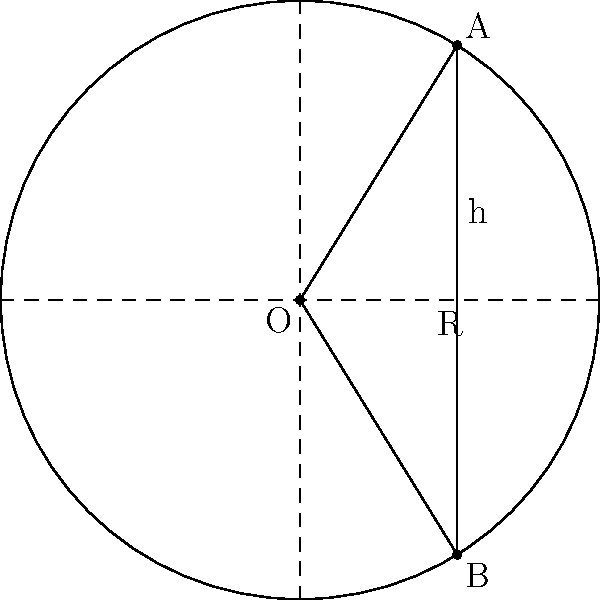A secure communication satellite orbits Earth in a circular path at an altitude of 35,786 km. Two ground stations in Europe, separated by a central angle of 90°, need to establish a connection through this satellite. If the Earth's radius is 6,371 km, what is the minimum distance between the satellite and the chord connecting the two ground stations? Let's approach this step-by-step:

1) First, we need to calculate the total radius of the orbit:
   $R = \text{Earth radius} + \text{Satellite altitude}$
   $R = 6,371 \text{ km} + 35,786 \text{ km} = 42,157 \text{ km}$

2) In the diagram, O represents the center of the Earth, A and B are the ground stations, and the circle represents the satellite's orbit.

3) The central angle between the ground stations is 90°, so triangle OAB is a right-angled triangle.

4) In a right-angled triangle, the hypotenuse (OA or OB) is the radius R, and we need to find the height (h) from the midpoint of AB to the circle.

5) We can use the Pythagorean theorem to find half of AB:
   $(\frac{1}{2}AB)^2 + h^2 = R^2$

6) In a 90° sector of a circle, half of the chord (AB/2) equals $R\sin(45°) = R/\sqrt{2}$

7) Substituting this into the Pythagorean theorem:
   $(R/\sqrt{2})^2 + h^2 = R^2$

8) Simplifying:
   $R^2/2 + h^2 = R^2$
   $h^2 = R^2 - R^2/2 = R^2/2$

9) Taking the square root:
   $h = R/\sqrt{2}$

10) Now we can calculate h:
    $h = 42,157 / \sqrt{2} \approx 29,809 \text{ km}$
Answer: 29,809 km 